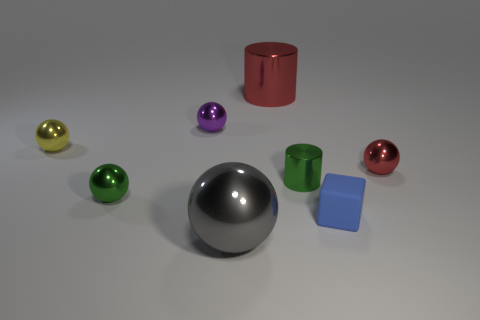There is a metal thing that is the same color as the tiny metal cylinder; what is its shape?
Ensure brevity in your answer.  Sphere. How many objects are either small shiny balls that are on the left side of the tiny red shiny thing or small purple metallic spheres?
Make the answer very short. 3. What size is the yellow thing that is the same material as the purple object?
Make the answer very short. Small. There is a gray shiny thing; is its size the same as the red shiny thing that is on the right side of the small matte cube?
Provide a short and direct response. No. The small sphere that is both on the right side of the green metallic ball and in front of the small purple sphere is what color?
Provide a short and direct response. Red. How many objects are shiny objects that are behind the tiny yellow thing or large things that are in front of the small yellow metallic ball?
Offer a terse response. 3. There is a large metal object behind the metallic cylinder that is in front of the big thing that is to the right of the big gray ball; what is its color?
Your answer should be compact. Red. Are there any other purple things that have the same shape as the purple thing?
Give a very brief answer. No. What number of small yellow cylinders are there?
Ensure brevity in your answer.  0. What is the shape of the tiny red shiny thing?
Your answer should be very brief. Sphere. 